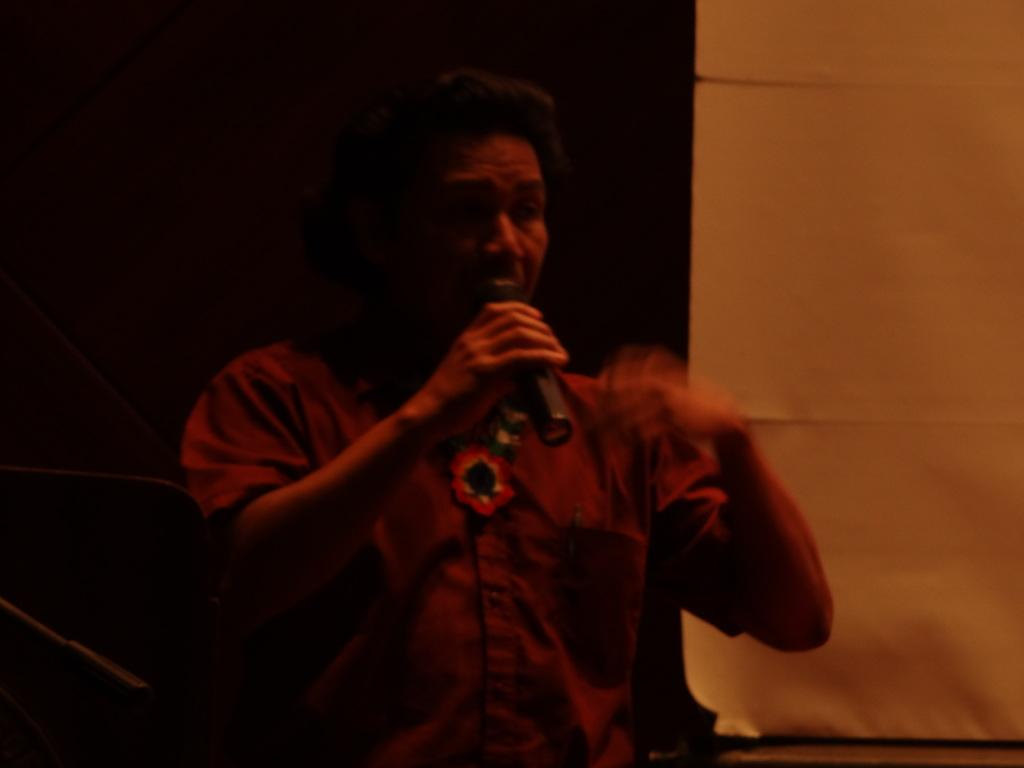What is the main subject of the image? There is a person in the image. What is the person wearing? The person is wearing a violet shirt. What is the person holding in his hand? The person is holding a mic in his hand. What is the person doing with the mic? The person is speaking in front of the mic. What can be seen in the right corner of the image? There is a yellow object in the right corner of the image. What type of operation is being performed by the person in the image? There is no operation being performed in the image; the person is speaking in front of a mic. Can you describe the battle scene taking place in the image? There is no battle scene present in the image; it features a person holding a mic and speaking. 